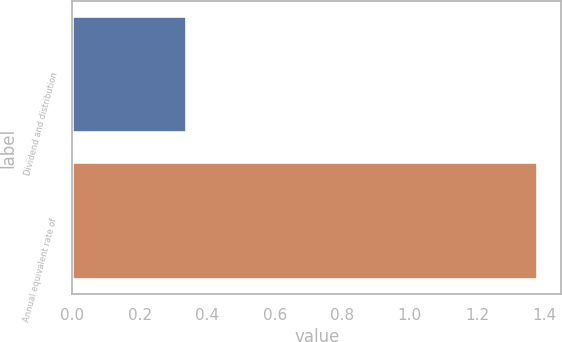<chart> <loc_0><loc_0><loc_500><loc_500><bar_chart><fcel>Dividend and distribution<fcel>Annual equivalent rate of<nl><fcel>0.34<fcel>1.38<nl></chart> 